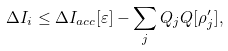Convert formula to latex. <formula><loc_0><loc_0><loc_500><loc_500>\Delta I _ { i } \leq \Delta I _ { a c c } [ \varepsilon ] - \sum _ { j } Q _ { j } Q [ \rho ^ { \prime } _ { j } ] ,</formula> 